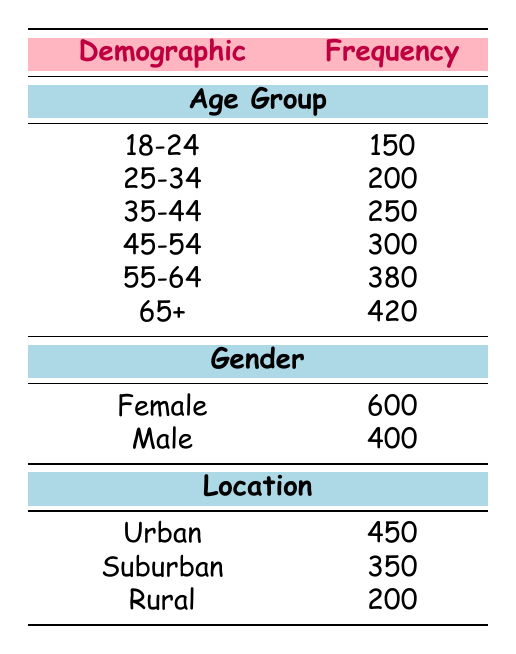What age group has the highest frequency in the audience demographics? By scanning the "Age Group" section of the table, we find the frequencies listed, with the "65+" group having the highest frequency of 420.
Answer: 65+ What is the total frequency of female audience members? The "Gender" section shows that the frequency for females is 600.
Answer: 600 Is the frequency of males greater than the frequency of the rural audience? The frequency for males is 400, and for rural, it is 200. Since 400 is greater than 200, the answer is yes.
Answer: Yes What is the difference in frequency between the age groups 45-54 and 25-34? The frequency for age group 45-54 is 300, and for age group 25-34 it is 200. Subtracting these gives 300 - 200 = 100.
Answer: 100 What is the combined frequency of urban and suburban audiences? The frequencies for urban and suburban are 450 and 350, respectively. Adding these together gives 450 + 350 = 800.
Answer: 800 Which demographic group has the lowest frequency? By examining the entire table, we see the lowest frequency is for the "Rural" location with 200.
Answer: Rural What percentage of the audience demographics is represented by the 55-64 age group? The frequency for the 55-64 age group is 380. To find the total audience frequency: 150 + 200 + 250 + 300 + 380 + 420 + 600 + 400 + 450 + 350 + 200 = 4100. The percentage is (380/4100) * 100 = 9.27%.
Answer: 9.27% Which demographic location has a frequency that is closest to the age group 45-54? The frequency for the age group 45-54 is 300, and the closest frequency in the location section is "Suburban" with 350, which is 50 more.
Answer: Suburban Is the combined frequency of the age group 18-24 and the male audience greater than the frequency of the age group 65+? The frequency of 18-24 is 150, and the male frequency is 400, which combines to 150 + 400 = 550. The frequency for age group 65+ is 420. Since 550 is greater than 420, the answer is yes.
Answer: Yes 